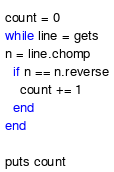<code> <loc_0><loc_0><loc_500><loc_500><_Ruby_>count = 0
while line = gets
n = line.chomp
  if n == n.reverse
    count += 1
  end
end

puts count
</code> 